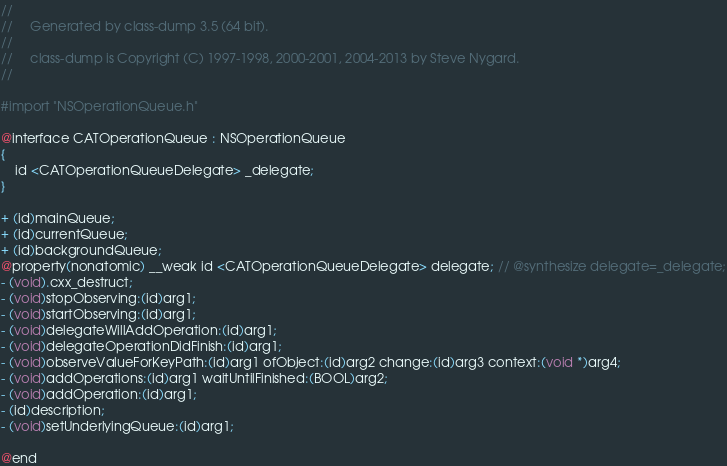Convert code to text. <code><loc_0><loc_0><loc_500><loc_500><_C_>//
//     Generated by class-dump 3.5 (64 bit).
//
//     class-dump is Copyright (C) 1997-1998, 2000-2001, 2004-2013 by Steve Nygard.
//

#import "NSOperationQueue.h"

@interface CATOperationQueue : NSOperationQueue
{
    id <CATOperationQueueDelegate> _delegate;
}

+ (id)mainQueue;
+ (id)currentQueue;
+ (id)backgroundQueue;
@property(nonatomic) __weak id <CATOperationQueueDelegate> delegate; // @synthesize delegate=_delegate;
- (void).cxx_destruct;
- (void)stopObserving:(id)arg1;
- (void)startObserving:(id)arg1;
- (void)delegateWillAddOperation:(id)arg1;
- (void)delegateOperationDidFinish:(id)arg1;
- (void)observeValueForKeyPath:(id)arg1 ofObject:(id)arg2 change:(id)arg3 context:(void *)arg4;
- (void)addOperations:(id)arg1 waitUntilFinished:(BOOL)arg2;
- (void)addOperation:(id)arg1;
- (id)description;
- (void)setUnderlyingQueue:(id)arg1;

@end

</code> 